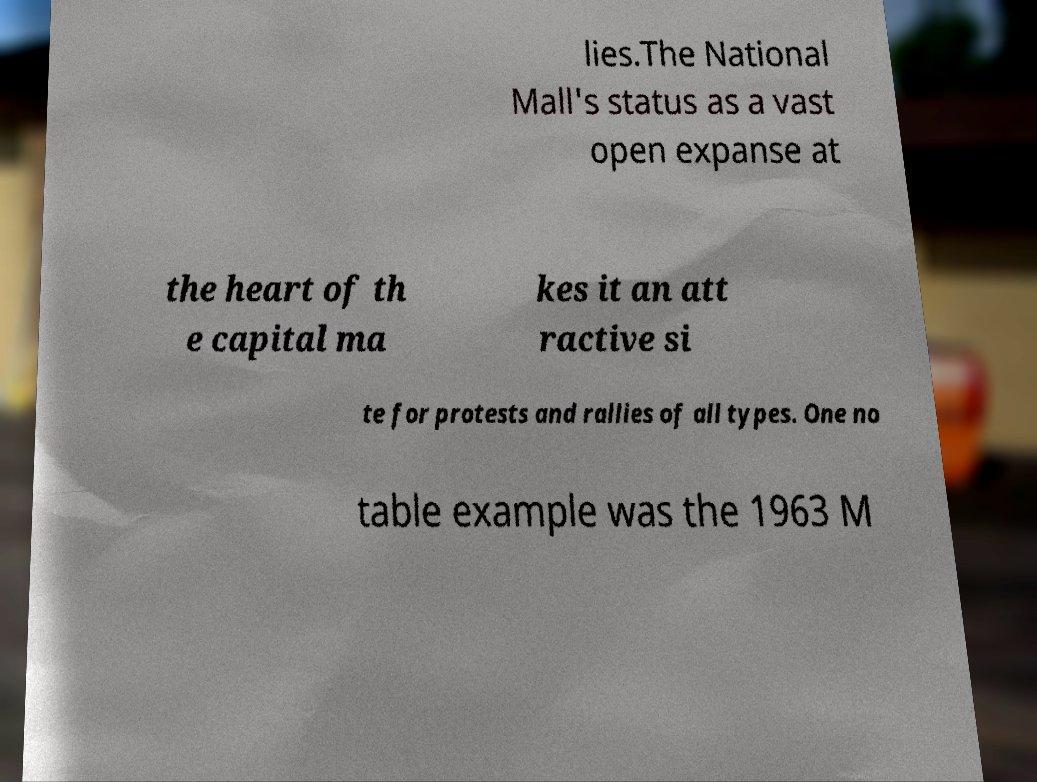I need the written content from this picture converted into text. Can you do that? lies.The National Mall's status as a vast open expanse at the heart of th e capital ma kes it an att ractive si te for protests and rallies of all types. One no table example was the 1963 M 